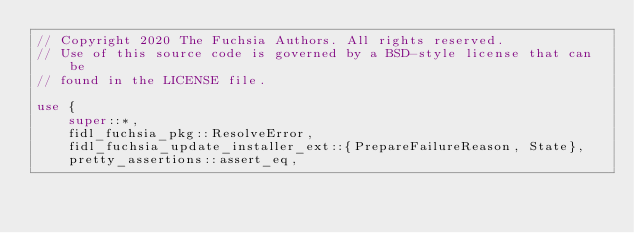Convert code to text. <code><loc_0><loc_0><loc_500><loc_500><_Rust_>// Copyright 2020 The Fuchsia Authors. All rights reserved.
// Use of this source code is governed by a BSD-style license that can be
// found in the LICENSE file.

use {
    super::*,
    fidl_fuchsia_pkg::ResolveError,
    fidl_fuchsia_update_installer_ext::{PrepareFailureReason, State},
    pretty_assertions::assert_eq,</code> 